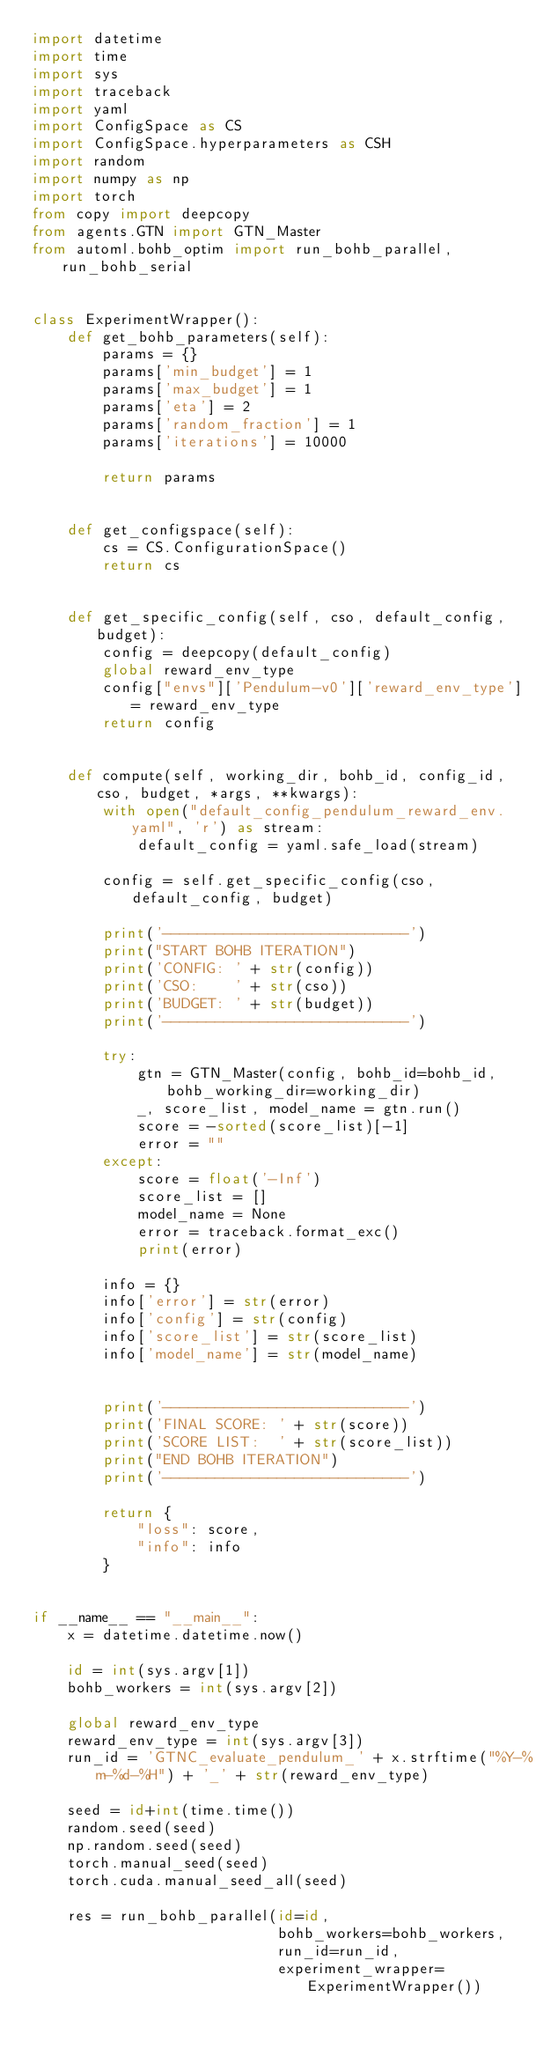Convert code to text. <code><loc_0><loc_0><loc_500><loc_500><_Python_>import datetime
import time
import sys
import traceback
import yaml
import ConfigSpace as CS
import ConfigSpace.hyperparameters as CSH
import random
import numpy as np
import torch
from copy import deepcopy
from agents.GTN import GTN_Master
from automl.bohb_optim import run_bohb_parallel, run_bohb_serial


class ExperimentWrapper():
    def get_bohb_parameters(self):
        params = {}
        params['min_budget'] = 1
        params['max_budget'] = 1
        params['eta'] = 2
        params['random_fraction'] = 1
        params['iterations'] = 10000

        return params


    def get_configspace(self):
        cs = CS.ConfigurationSpace()
        return cs


    def get_specific_config(self, cso, default_config, budget):
        config = deepcopy(default_config)
        global reward_env_type
        config["envs"]['Pendulum-v0']['reward_env_type'] = reward_env_type
        return config


    def compute(self, working_dir, bohb_id, config_id, cso, budget, *args, **kwargs):
        with open("default_config_pendulum_reward_env.yaml", 'r') as stream:
            default_config = yaml.safe_load(stream)

        config = self.get_specific_config(cso, default_config, budget)

        print('----------------------------')
        print("START BOHB ITERATION")
        print('CONFIG: ' + str(config))
        print('CSO:    ' + str(cso))
        print('BUDGET: ' + str(budget))
        print('----------------------------')

        try:
            gtn = GTN_Master(config, bohb_id=bohb_id, bohb_working_dir=working_dir)
            _, score_list, model_name = gtn.run()
            score = -sorted(score_list)[-1]
            error = ""
        except:
            score = float('-Inf')
            score_list = []
            model_name = None
            error = traceback.format_exc()
            print(error)

        info = {}
        info['error'] = str(error)
        info['config'] = str(config)
        info['score_list'] = str(score_list)
        info['model_name'] = str(model_name)


        print('----------------------------')
        print('FINAL SCORE: ' + str(score))
        print('SCORE LIST:  ' + str(score_list))
        print("END BOHB ITERATION")
        print('----------------------------')

        return {
            "loss": score,
            "info": info
        }


if __name__ == "__main__":
    x = datetime.datetime.now()

    id = int(sys.argv[1])
    bohb_workers = int(sys.argv[2])

    global reward_env_type
    reward_env_type = int(sys.argv[3])
    run_id = 'GTNC_evaluate_pendulum_' + x.strftime("%Y-%m-%d-%H") + '_' + str(reward_env_type)

    seed = id+int(time.time())
    random.seed(seed)
    np.random.seed(seed)
    torch.manual_seed(seed)
    torch.cuda.manual_seed_all(seed)

    res = run_bohb_parallel(id=id,
                            bohb_workers=bohb_workers,
                            run_id=run_id,
                            experiment_wrapper=ExperimentWrapper())
</code> 